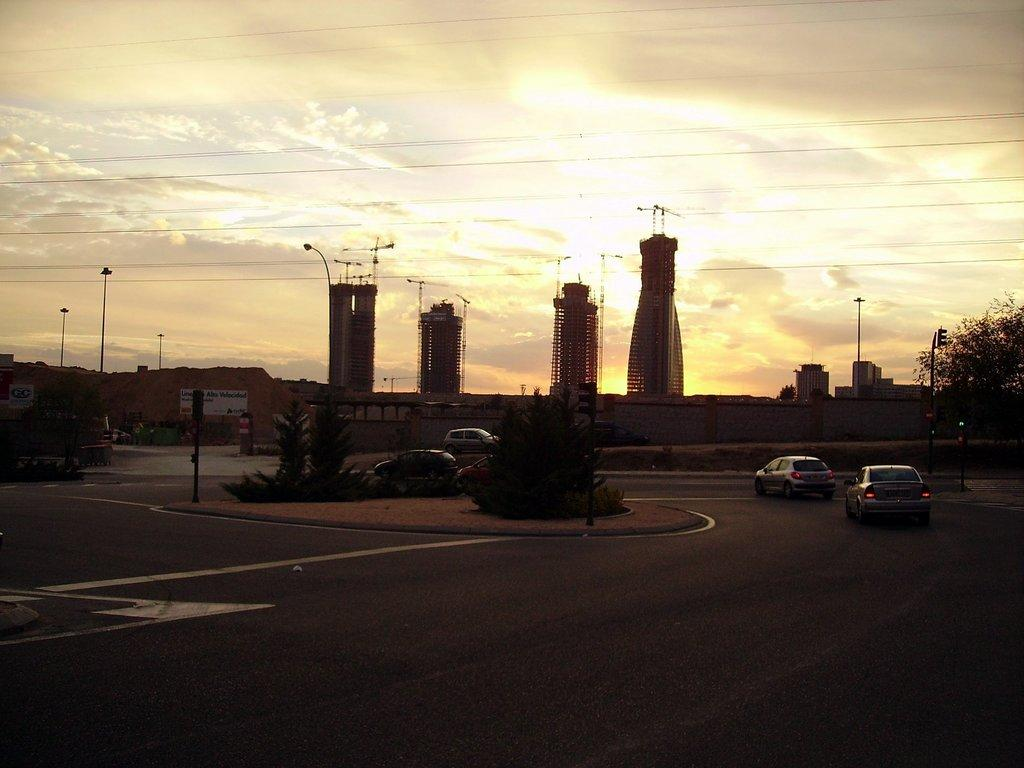What is the condition of the sky in the image? The sky is cloudy in the image. What can be seen on the road in the image? Vehicles are on the road in the image. What type of structures are present in the image? There are buildings in the image. What are the light poles used for in the image? The light poles are present in the image to provide illumination. What type of advertisement is visible in the image? There is a hoarding in the image. What type of vegetation is visible in the image? Plants and a tree are visible in the image. What shape is the brick used to construct the buildings in the image? There is no mention of bricks or their shape in the image; the buildings are not described in terms of their construction materials. How does the expansion of the tree affect the surrounding area in the image? There is no indication of the tree's expansion or its impact on the surrounding area in the image. 